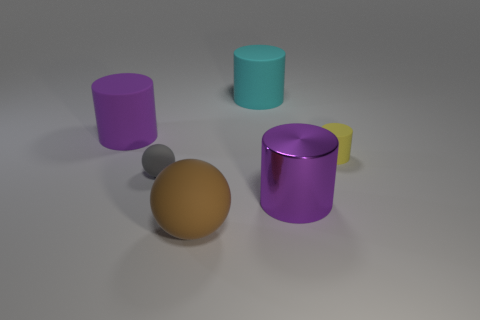Subtract 1 cylinders. How many cylinders are left? 3 Add 2 tiny yellow things. How many objects exist? 8 Subtract all cylinders. How many objects are left? 2 Add 6 yellow rubber things. How many yellow rubber things exist? 7 Subtract 1 brown spheres. How many objects are left? 5 Subtract all cylinders. Subtract all big purple things. How many objects are left? 0 Add 5 purple cylinders. How many purple cylinders are left? 7 